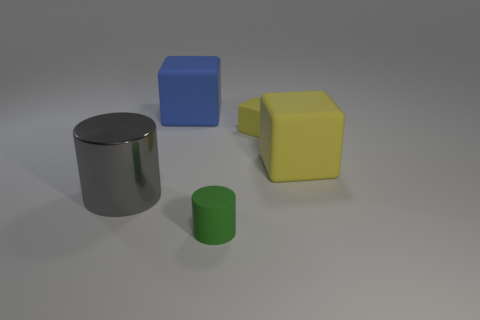Add 1 small red shiny blocks. How many objects exist? 6 Subtract all blocks. How many objects are left? 2 Subtract all yellow rubber cubes. Subtract all blue metal cylinders. How many objects are left? 3 Add 5 small yellow blocks. How many small yellow blocks are left? 6 Add 4 big blue blocks. How many big blue blocks exist? 5 Subtract 0 green cubes. How many objects are left? 5 